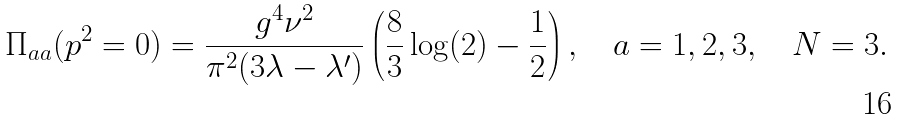<formula> <loc_0><loc_0><loc_500><loc_500>\Pi _ { a a } ( p ^ { 2 } = 0 ) = \frac { g ^ { 4 } \nu ^ { 2 } } { \pi ^ { 2 } ( 3 \lambda - \lambda ^ { \prime } ) } \left ( \frac { 8 } { 3 } \log ( 2 ) - \frac { 1 } { 2 } \right ) , \quad a = 1 , 2 , 3 , \quad N = 3 .</formula> 